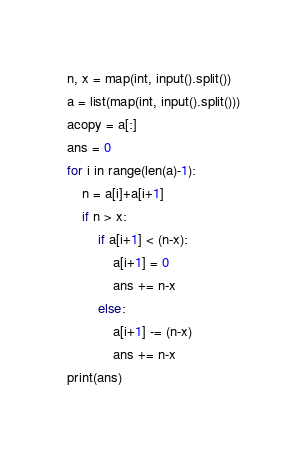Convert code to text. <code><loc_0><loc_0><loc_500><loc_500><_Python_>n, x = map(int, input().split())
a = list(map(int, input().split()))
acopy = a[:]
ans = 0
for i in range(len(a)-1):
    n = a[i]+a[i+1]
    if n > x:
        if a[i+1] < (n-x):
            a[i+1] = 0
            ans += n-x
        else:
            a[i+1] -= (n-x)
            ans += n-x
print(ans)
</code> 